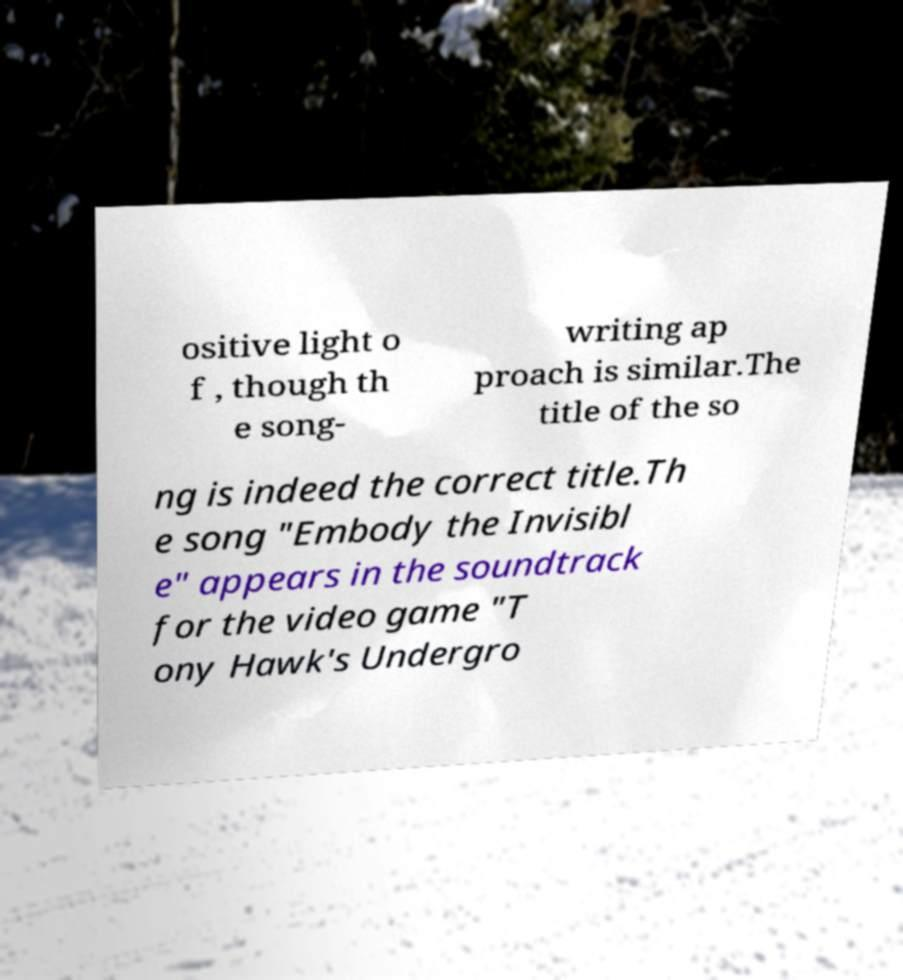What messages or text are displayed in this image? I need them in a readable, typed format. ositive light o f , though th e song- writing ap proach is similar.The title of the so ng is indeed the correct title.Th e song "Embody the Invisibl e" appears in the soundtrack for the video game "T ony Hawk's Undergro 